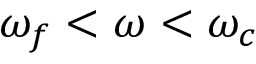Convert formula to latex. <formula><loc_0><loc_0><loc_500><loc_500>\omega _ { f } < \omega < \omega _ { c }</formula> 